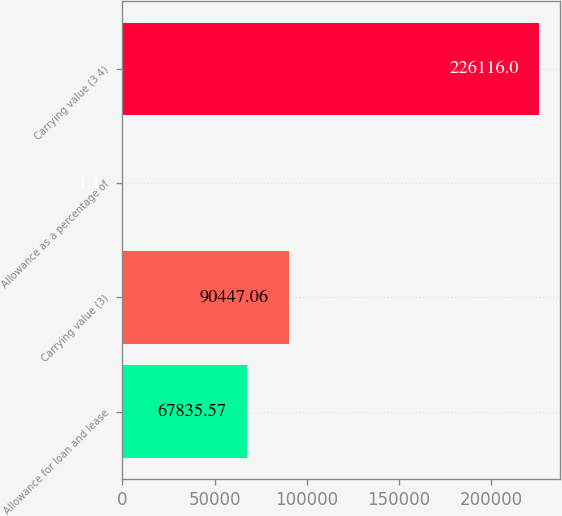Convert chart to OTSL. <chart><loc_0><loc_0><loc_500><loc_500><bar_chart><fcel>Allowance for loan and lease<fcel>Carrying value (3)<fcel>Allowance as a percentage of<fcel>Carrying value (3 4)<nl><fcel>67835.6<fcel>90447.1<fcel>1.1<fcel>226116<nl></chart> 